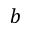<formula> <loc_0><loc_0><loc_500><loc_500>b</formula> 